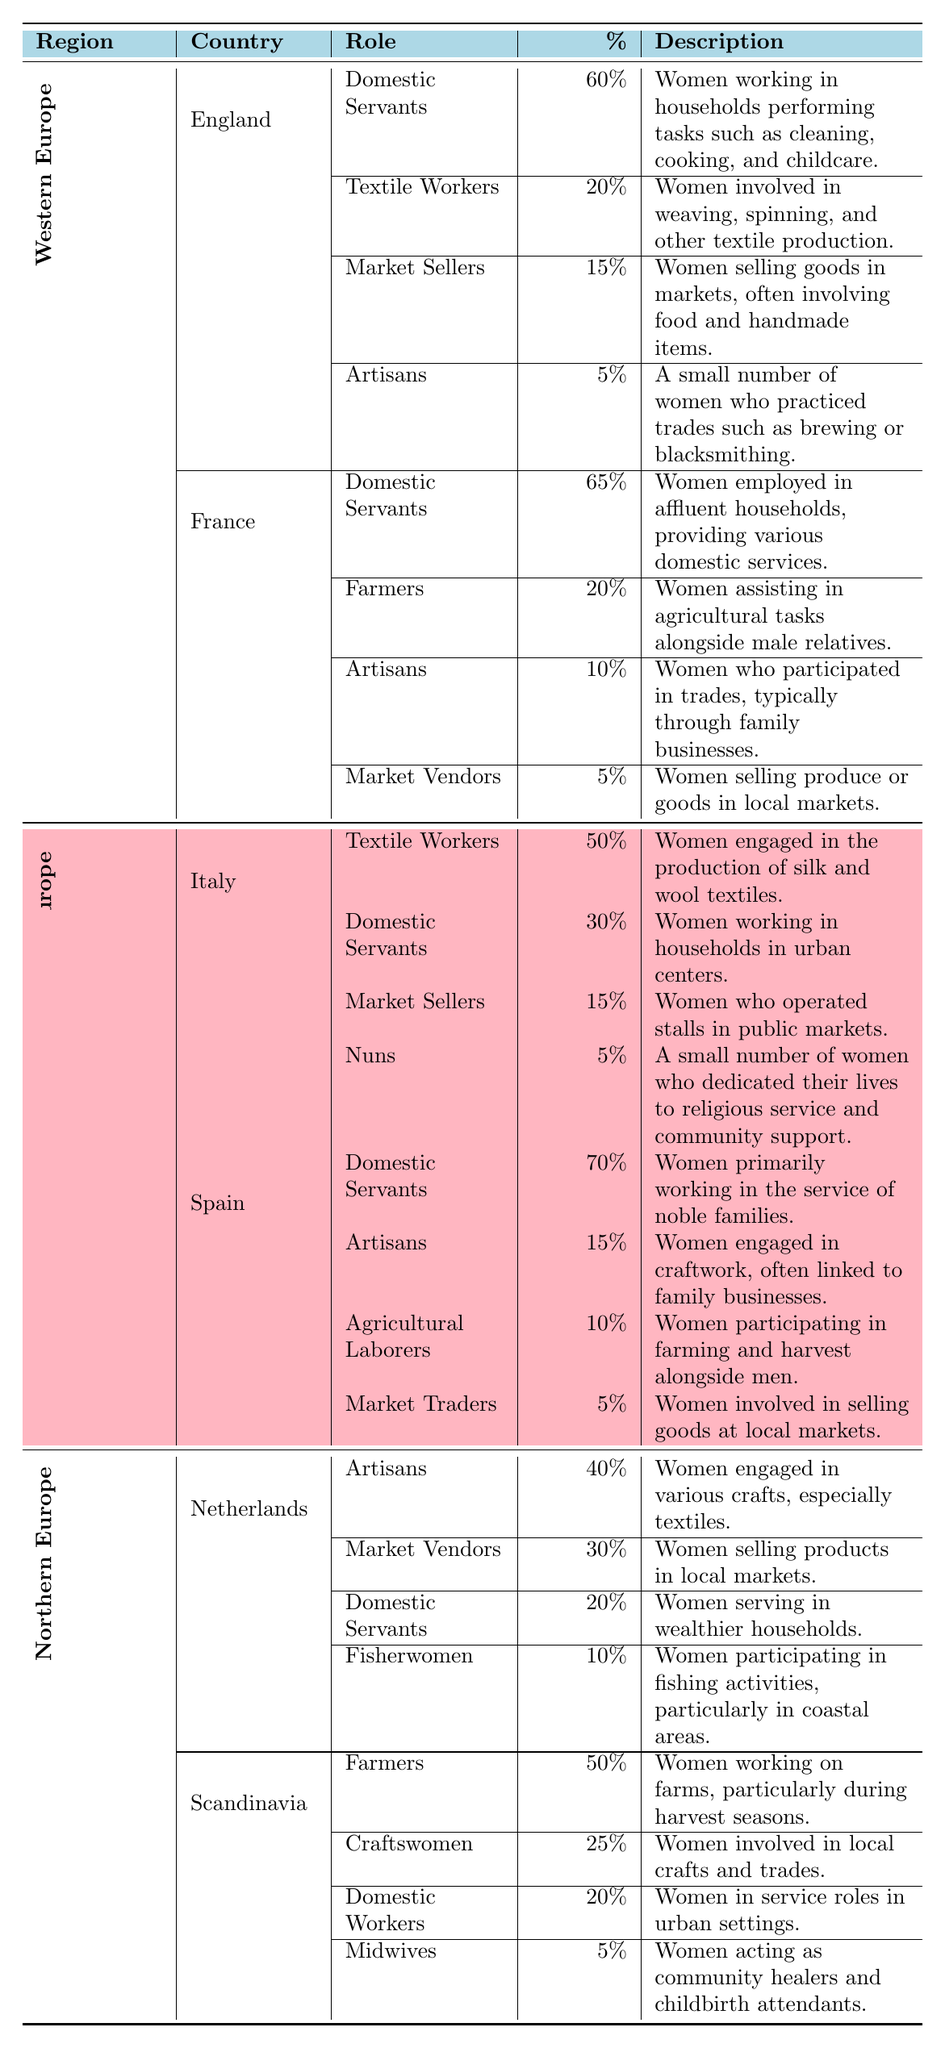What is the role with the highest percentage of employment for women in Spain? The role with the highest percentage is "Domestic Servants," accounting for 70% of women's employment in Spain according to the table.
Answer: Domestic Servants Which country in Southern Europe has the least percentage of women employed as artisans? According to the table, Italy has 5% of women employed as artisans, while Spain has 15%. Therefore, Italy has the least percentage.
Answer: Italy What is the average percentage of women working as market sellers in Western Europe? In England, the percentage of women as market sellers is 15%, and in France, it is 5%. To find the average: (15 + 5)/2 = 20/2 = 10.
Answer: 10 Is there a role with the same percentage of employment for women in both England and France? By reviewing the data, the role of "Market Sellers" in England is 15%, while in France, "Market Vendors" is 5%. Since there are no identical percentages in the same roles for these countries, the answer is no.
Answer: No Which region has the highest overall percentage of women employed as domestic servants? Summing the percentages from all countries in each region for domestic servants: Western Europe (England 60% + France 65% = 125%), Southern Europe (Italy 30% + Spain 70% = 100%), and Northern Europe (Netherlands 20% + Scandinavia 20% = 40%). The highest is Western Europe, with 125%.
Answer: Western Europe What percentage of women in the Netherlands are engaged in fishing activities? The table states that 10% of women in the Netherlands are reported as fisherwomen, which directly answers the question.
Answer: 10% Which role do Scandinavian women have a higher percentage in compared to farmers in Italy? In Scandinavia, women engaged in farming is 50%, compared to Italy where farmers make up 20%. So, craftswomen, at 25%, is higher than farmers in Italy.
Answer: Craftswomen What is the total percentage of women employed as artisans in Western Europe? The total would be the sum of artisans in England (5%) and in France (10%), leading to a total of 5 + 10 = 15%.
Answer: 15% Do more women work as domestic servants in Italy or in England? In the table, it shows that 30% of women in Italy are domestic servants, whereas in England, that figure stands at 60%. Thus, more women work as domestic servants in England.
Answer: England 